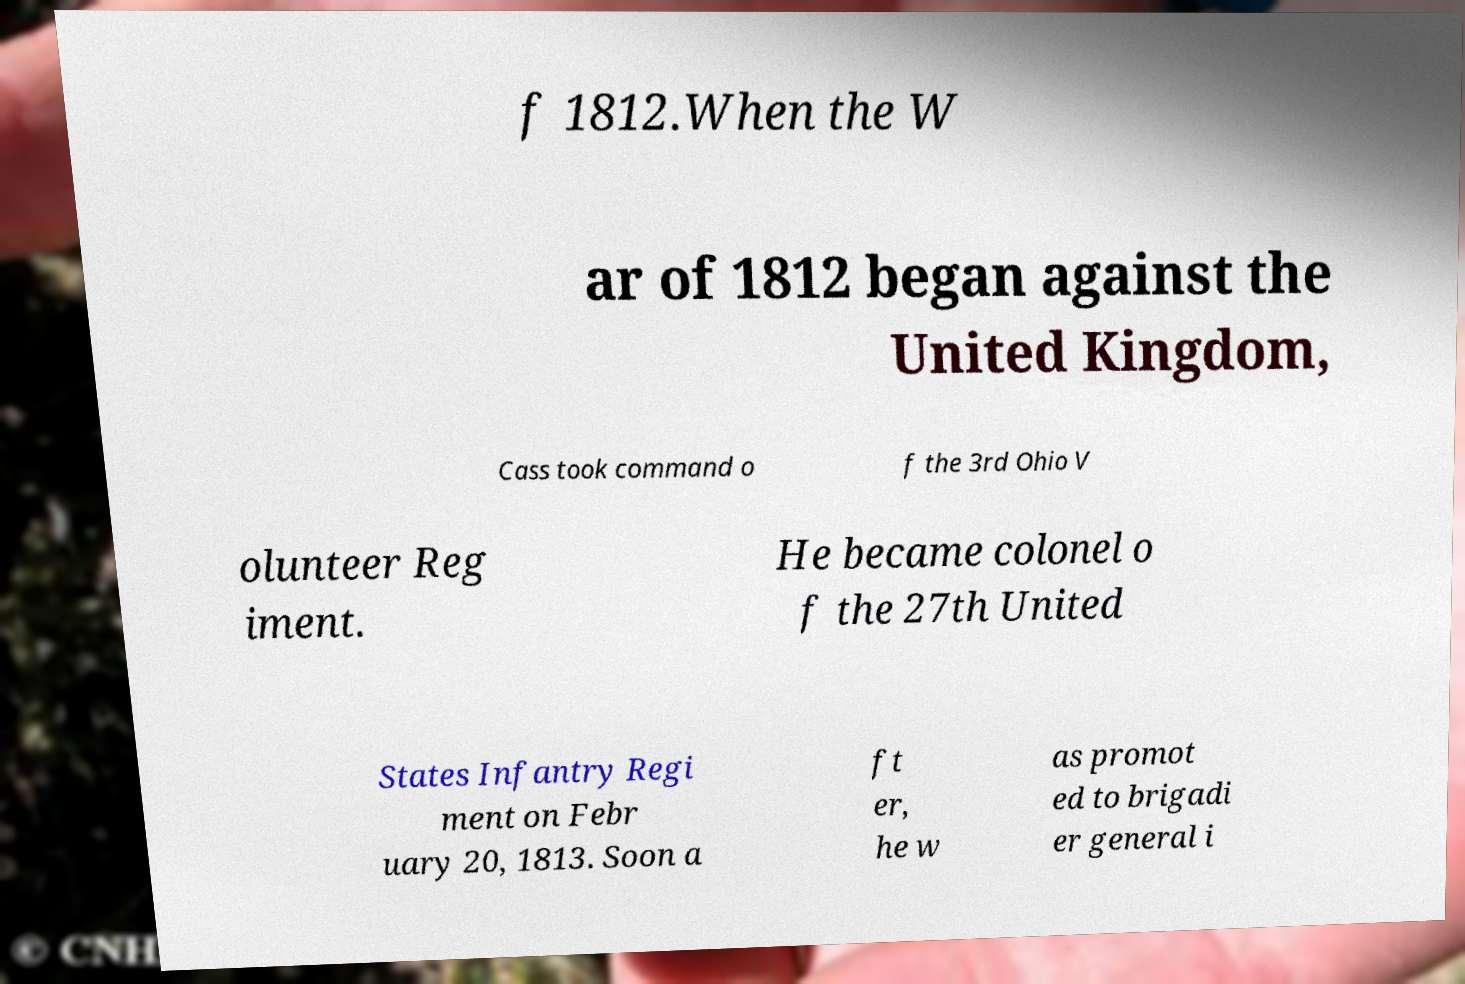What messages or text are displayed in this image? I need them in a readable, typed format. f 1812.When the W ar of 1812 began against the United Kingdom, Cass took command o f the 3rd Ohio V olunteer Reg iment. He became colonel o f the 27th United States Infantry Regi ment on Febr uary 20, 1813. Soon a ft er, he w as promot ed to brigadi er general i 